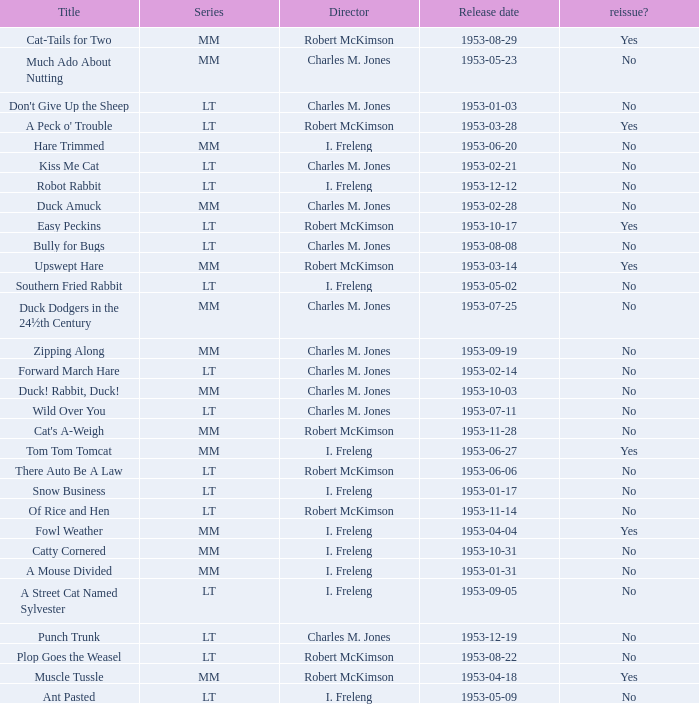Was there a reissue of the film released on 1953-10-03? No. I'm looking to parse the entire table for insights. Could you assist me with that? {'header': ['Title', 'Series', 'Director', 'Release date', 'reissue?'], 'rows': [['Cat-Tails for Two', 'MM', 'Robert McKimson', '1953-08-29', 'Yes'], ['Much Ado About Nutting', 'MM', 'Charles M. Jones', '1953-05-23', 'No'], ["Don't Give Up the Sheep", 'LT', 'Charles M. Jones', '1953-01-03', 'No'], ["A Peck o' Trouble", 'LT', 'Robert McKimson', '1953-03-28', 'Yes'], ['Hare Trimmed', 'MM', 'I. Freleng', '1953-06-20', 'No'], ['Kiss Me Cat', 'LT', 'Charles M. Jones', '1953-02-21', 'No'], ['Robot Rabbit', 'LT', 'I. Freleng', '1953-12-12', 'No'], ['Duck Amuck', 'MM', 'Charles M. Jones', '1953-02-28', 'No'], ['Easy Peckins', 'LT', 'Robert McKimson', '1953-10-17', 'Yes'], ['Bully for Bugs', 'LT', 'Charles M. Jones', '1953-08-08', 'No'], ['Upswept Hare', 'MM', 'Robert McKimson', '1953-03-14', 'Yes'], ['Southern Fried Rabbit', 'LT', 'I. Freleng', '1953-05-02', 'No'], ['Duck Dodgers in the 24½th Century', 'MM', 'Charles M. Jones', '1953-07-25', 'No'], ['Zipping Along', 'MM', 'Charles M. Jones', '1953-09-19', 'No'], ['Forward March Hare', 'LT', 'Charles M. Jones', '1953-02-14', 'No'], ['Duck! Rabbit, Duck!', 'MM', 'Charles M. Jones', '1953-10-03', 'No'], ['Wild Over You', 'LT', 'Charles M. Jones', '1953-07-11', 'No'], ["Cat's A-Weigh", 'MM', 'Robert McKimson', '1953-11-28', 'No'], ['Tom Tom Tomcat', 'MM', 'I. Freleng', '1953-06-27', 'Yes'], ['There Auto Be A Law', 'LT', 'Robert McKimson', '1953-06-06', 'No'], ['Snow Business', 'LT', 'I. Freleng', '1953-01-17', 'No'], ['Of Rice and Hen', 'LT', 'Robert McKimson', '1953-11-14', 'No'], ['Fowl Weather', 'MM', 'I. Freleng', '1953-04-04', 'Yes'], ['Catty Cornered', 'MM', 'I. Freleng', '1953-10-31', 'No'], ['A Mouse Divided', 'MM', 'I. Freleng', '1953-01-31', 'No'], ['A Street Cat Named Sylvester', 'LT', 'I. Freleng', '1953-09-05', 'No'], ['Punch Trunk', 'LT', 'Charles M. Jones', '1953-12-19', 'No'], ['Plop Goes the Weasel', 'LT', 'Robert McKimson', '1953-08-22', 'No'], ['Muscle Tussle', 'MM', 'Robert McKimson', '1953-04-18', 'Yes'], ['Ant Pasted', 'LT', 'I. Freleng', '1953-05-09', 'No']]} 